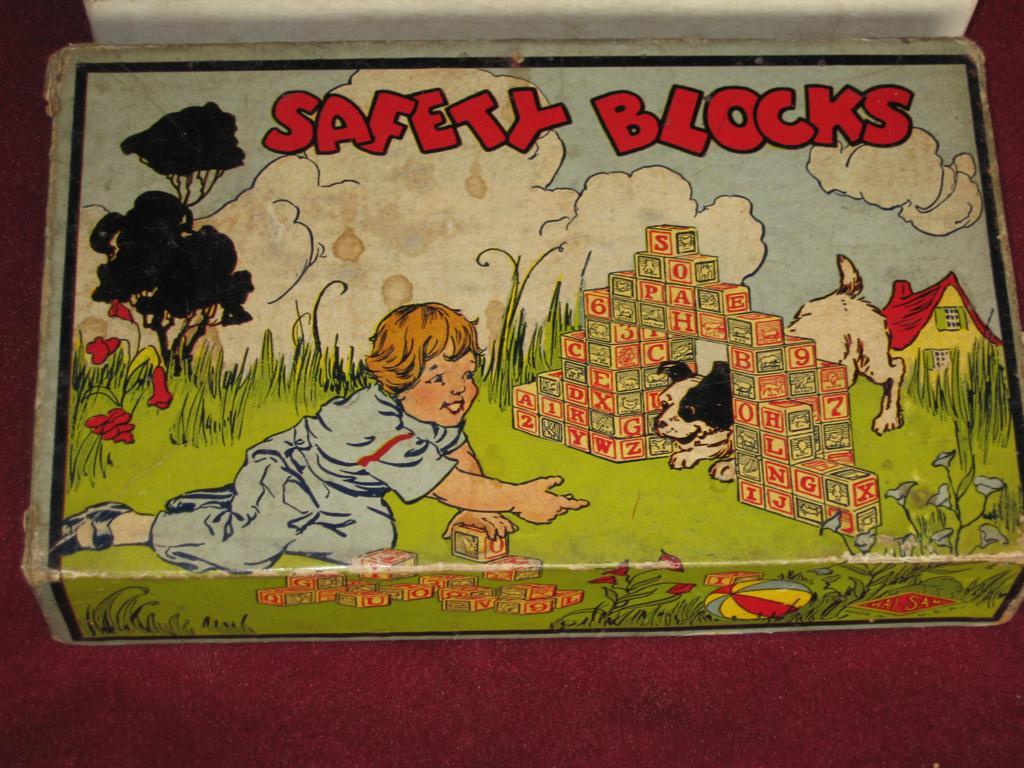How would you summarize this image in a sentence or two? In the image there is a box with print of a baby playing on grassland along with puppy and a house behind it and above its sky with clouds on a table. 